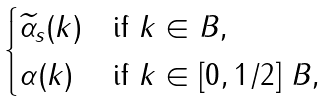<formula> <loc_0><loc_0><loc_500><loc_500>\begin{cases} \widetilde { \alpha } _ { s } ( k ) & \text {if } k \in B , \\ \alpha ( k ) & \text {if } k \in [ 0 , 1 / 2 ] \ B , \end{cases}</formula> 